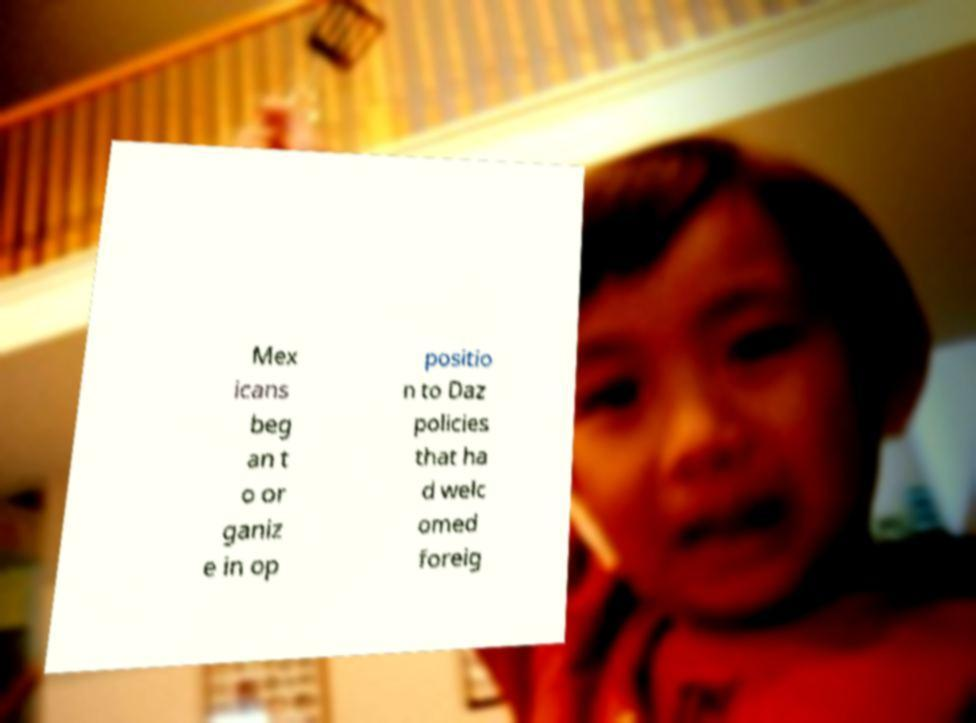Can you read and provide the text displayed in the image?This photo seems to have some interesting text. Can you extract and type it out for me? Mex icans beg an t o or ganiz e in op positio n to Daz policies that ha d welc omed foreig 